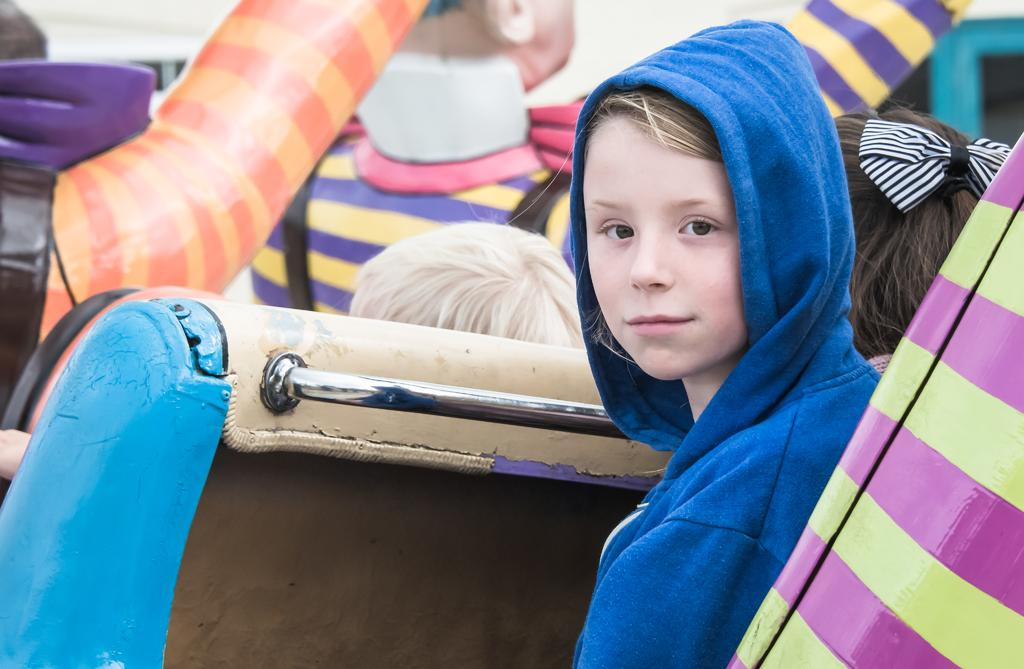How many people are in the image? There are persons in the image. What can be used for sitting in the image? There are seats in the image. What object can be used for holding or pulling in the image? There is a handle in the image. Can you describe the boy in the image? The boy is in the image, and he is wearing a blue sweater. What type of rod is the boy using to measure his growth in the image? There is no rod present in the image, and the boy is not measuring his growth. 